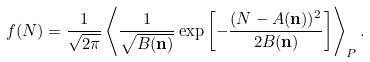<formula> <loc_0><loc_0><loc_500><loc_500>f ( N ) = \frac { 1 } { \sqrt { 2 \pi } } \left < \frac { 1 } { \sqrt { B ( { \mathbf n } ) } } \exp \left [ - \frac { ( N - A ( { \mathbf n } ) ) ^ { 2 } } { 2 B ( { \mathbf n } ) } \right ] \right > _ { P } .</formula> 